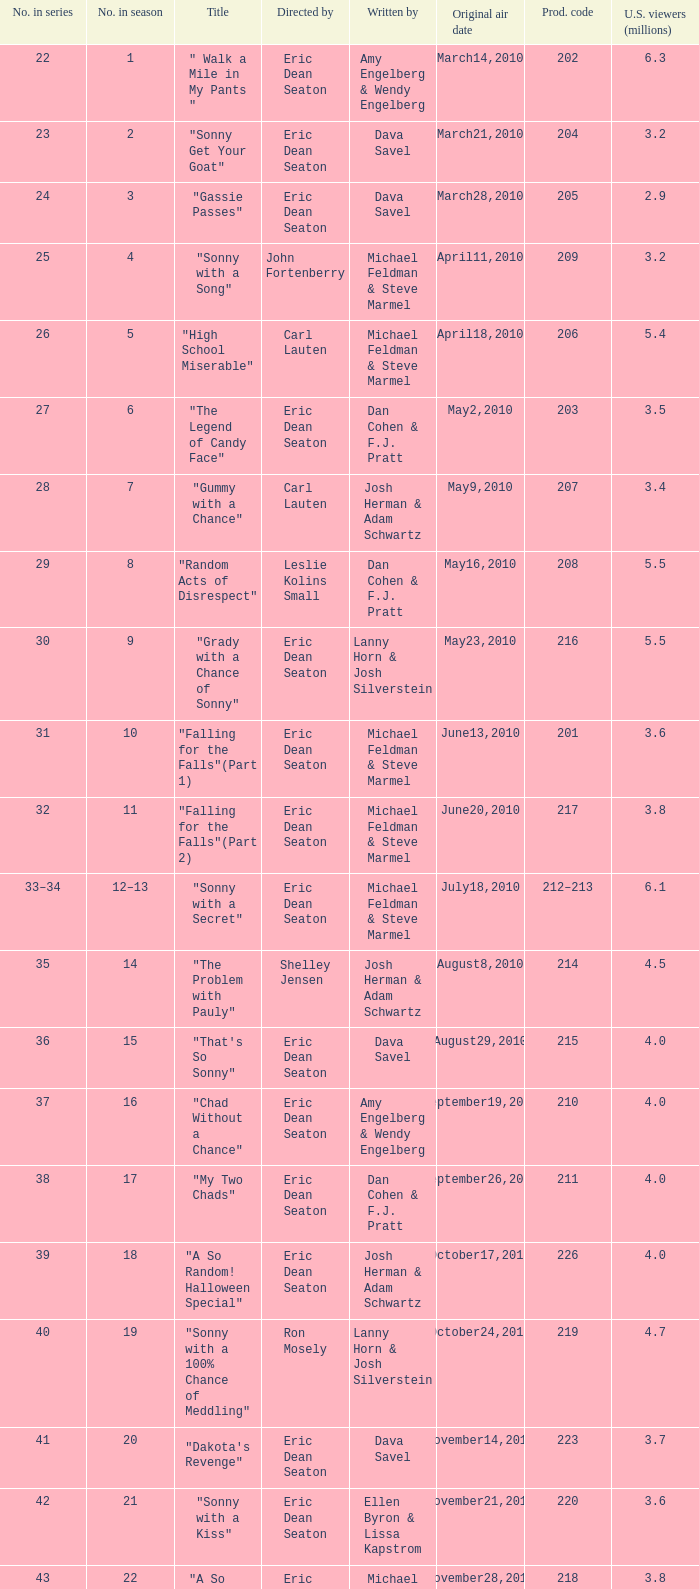In the season, how many episodes were named "that's so sonny"? 1.0. Help me parse the entirety of this table. {'header': ['No. in series', 'No. in season', 'Title', 'Directed by', 'Written by', 'Original air date', 'Prod. code', 'U.S. viewers (millions)'], 'rows': [['22', '1', '" Walk a Mile in My Pants "', 'Eric Dean Seaton', 'Amy Engelberg & Wendy Engelberg', 'March14,2010', '202', '6.3'], ['23', '2', '"Sonny Get Your Goat"', 'Eric Dean Seaton', 'Dava Savel', 'March21,2010', '204', '3.2'], ['24', '3', '"Gassie Passes"', 'Eric Dean Seaton', 'Dava Savel', 'March28,2010', '205', '2.9'], ['25', '4', '"Sonny with a Song"', 'John Fortenberry', 'Michael Feldman & Steve Marmel', 'April11,2010', '209', '3.2'], ['26', '5', '"High School Miserable"', 'Carl Lauten', 'Michael Feldman & Steve Marmel', 'April18,2010', '206', '5.4'], ['27', '6', '"The Legend of Candy Face"', 'Eric Dean Seaton', 'Dan Cohen & F.J. Pratt', 'May2,2010', '203', '3.5'], ['28', '7', '"Gummy with a Chance"', 'Carl Lauten', 'Josh Herman & Adam Schwartz', 'May9,2010', '207', '3.4'], ['29', '8', '"Random Acts of Disrespect"', 'Leslie Kolins Small', 'Dan Cohen & F.J. Pratt', 'May16,2010', '208', '5.5'], ['30', '9', '"Grady with a Chance of Sonny"', 'Eric Dean Seaton', 'Lanny Horn & Josh Silverstein', 'May23,2010', '216', '5.5'], ['31', '10', '"Falling for the Falls"(Part 1)', 'Eric Dean Seaton', 'Michael Feldman & Steve Marmel', 'June13,2010', '201', '3.6'], ['32', '11', '"Falling for the Falls"(Part 2)', 'Eric Dean Seaton', 'Michael Feldman & Steve Marmel', 'June20,2010', '217', '3.8'], ['33–34', '12–13', '"Sonny with a Secret"', 'Eric Dean Seaton', 'Michael Feldman & Steve Marmel', 'July18,2010', '212–213', '6.1'], ['35', '14', '"The Problem with Pauly"', 'Shelley Jensen', 'Josh Herman & Adam Schwartz', 'August8,2010', '214', '4.5'], ['36', '15', '"That\'s So Sonny"', 'Eric Dean Seaton', 'Dava Savel', 'August29,2010', '215', '4.0'], ['37', '16', '"Chad Without a Chance"', 'Eric Dean Seaton', 'Amy Engelberg & Wendy Engelberg', 'September19,2010', '210', '4.0'], ['38', '17', '"My Two Chads"', 'Eric Dean Seaton', 'Dan Cohen & F.J. Pratt', 'September26,2010', '211', '4.0'], ['39', '18', '"A So Random! Halloween Special"', 'Eric Dean Seaton', 'Josh Herman & Adam Schwartz', 'October17,2010', '226', '4.0'], ['40', '19', '"Sonny with a 100% Chance of Meddling"', 'Ron Mosely', 'Lanny Horn & Josh Silverstein', 'October24,2010', '219', '4.7'], ['41', '20', '"Dakota\'s Revenge"', 'Eric Dean Seaton', 'Dava Savel', 'November14,2010', '223', '3.7'], ['42', '21', '"Sonny with a Kiss"', 'Eric Dean Seaton', 'Ellen Byron & Lissa Kapstrom', 'November21,2010', '220', '3.6'], ['43', '22', '"A So Random! Holiday Special"', 'Eric Dean Seaton', 'Michael Feldman & Steve Marmel', 'November28,2010', '218', '3.8'], ['44', '23', '"Sonny with a Grant"', 'Eric Dean Seaton', 'Michael Feldman & Steve Marmel', 'December5,2010', '221', '4.0'], ['45', '24', '"Marshall with a Chance"', 'Shannon Flynn', 'Carla Banks Waddles', 'December12,2010', '224', '3.2'], ['46', '25', '"Sonny with a Choice"', 'Eric Dean Seaton', 'Dan Cohen & F.J. Pratt', 'December19,2010', '222', '4.7']]} 